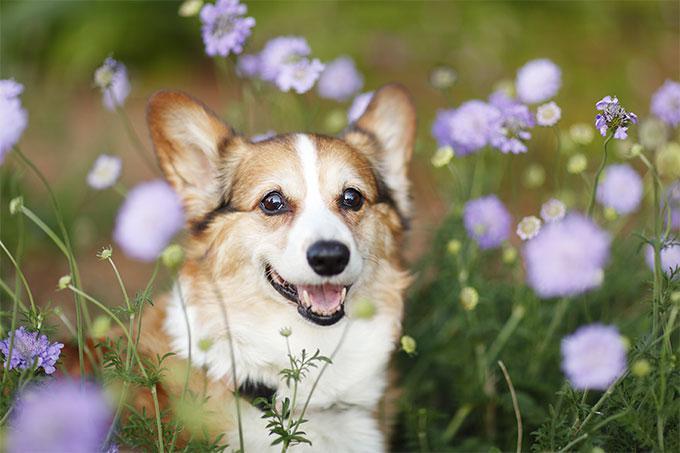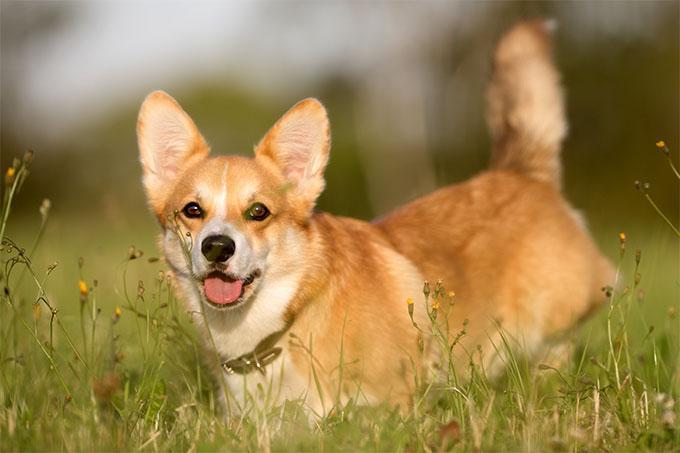The first image is the image on the left, the second image is the image on the right. Evaluate the accuracy of this statement regarding the images: "At least one dog has some black fur.". Is it true? Answer yes or no. No. The first image is the image on the left, the second image is the image on the right. Analyze the images presented: Is the assertion "An image features a multi-colored dog with black markings that create a mask-look." valid? Answer yes or no. No. 